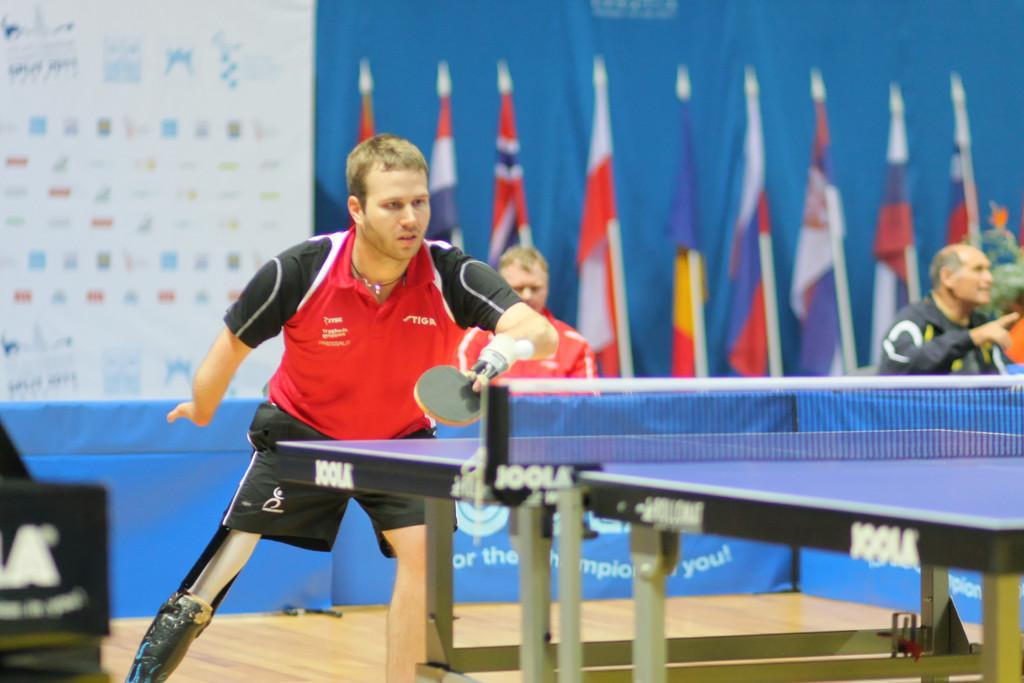<image>
Relay a brief, clear account of the picture shown. a man plays on a Joolk ping pong table 